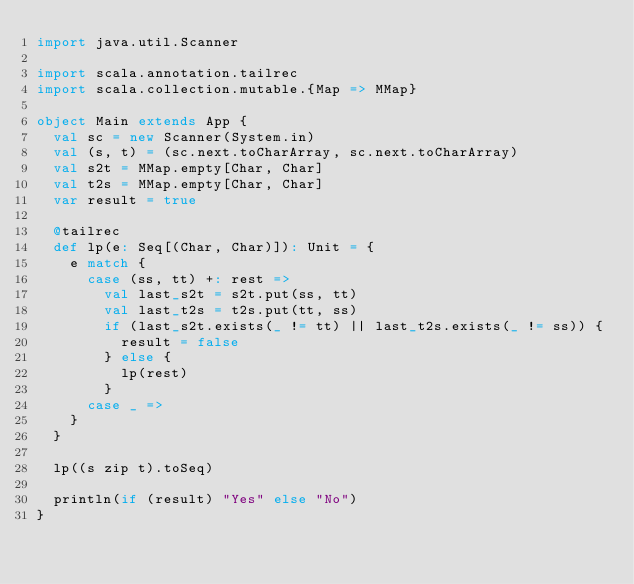<code> <loc_0><loc_0><loc_500><loc_500><_Scala_>import java.util.Scanner

import scala.annotation.tailrec
import scala.collection.mutable.{Map => MMap}

object Main extends App {
  val sc = new Scanner(System.in)
  val (s, t) = (sc.next.toCharArray, sc.next.toCharArray)
  val s2t = MMap.empty[Char, Char]
  val t2s = MMap.empty[Char, Char]
  var result = true

  @tailrec
  def lp(e: Seq[(Char, Char)]): Unit = {
    e match {
      case (ss, tt) +: rest =>
        val last_s2t = s2t.put(ss, tt)
        val last_t2s = t2s.put(tt, ss)
        if (last_s2t.exists(_ != tt) || last_t2s.exists(_ != ss)) {
          result = false
        } else {
          lp(rest)
        }
      case _ =>
    }
  }

  lp((s zip t).toSeq)

  println(if (result) "Yes" else "No")
}
</code> 